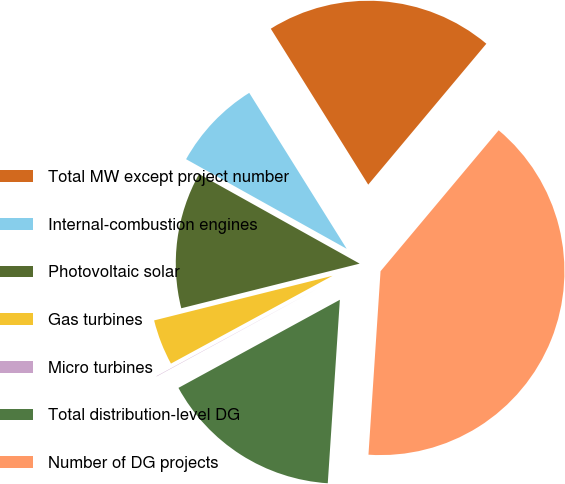Convert chart to OTSL. <chart><loc_0><loc_0><loc_500><loc_500><pie_chart><fcel>Total MW except project number<fcel>Internal-combustion engines<fcel>Photovoltaic solar<fcel>Gas turbines<fcel>Micro turbines<fcel>Total distribution-level DG<fcel>Number of DG projects<nl><fcel>19.99%<fcel>8.01%<fcel>12.0%<fcel>4.02%<fcel>0.03%<fcel>16.0%<fcel>39.94%<nl></chart> 